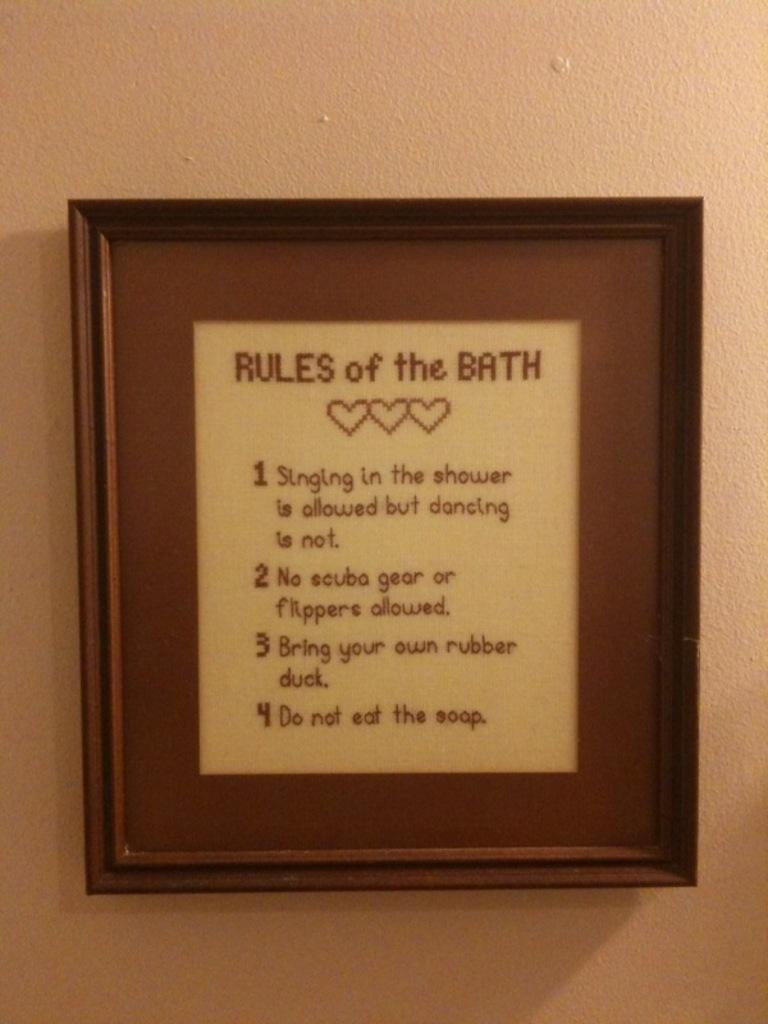<image>
Create a compact narrative representing the image presented. a frame that has rules of birth at the top of it 